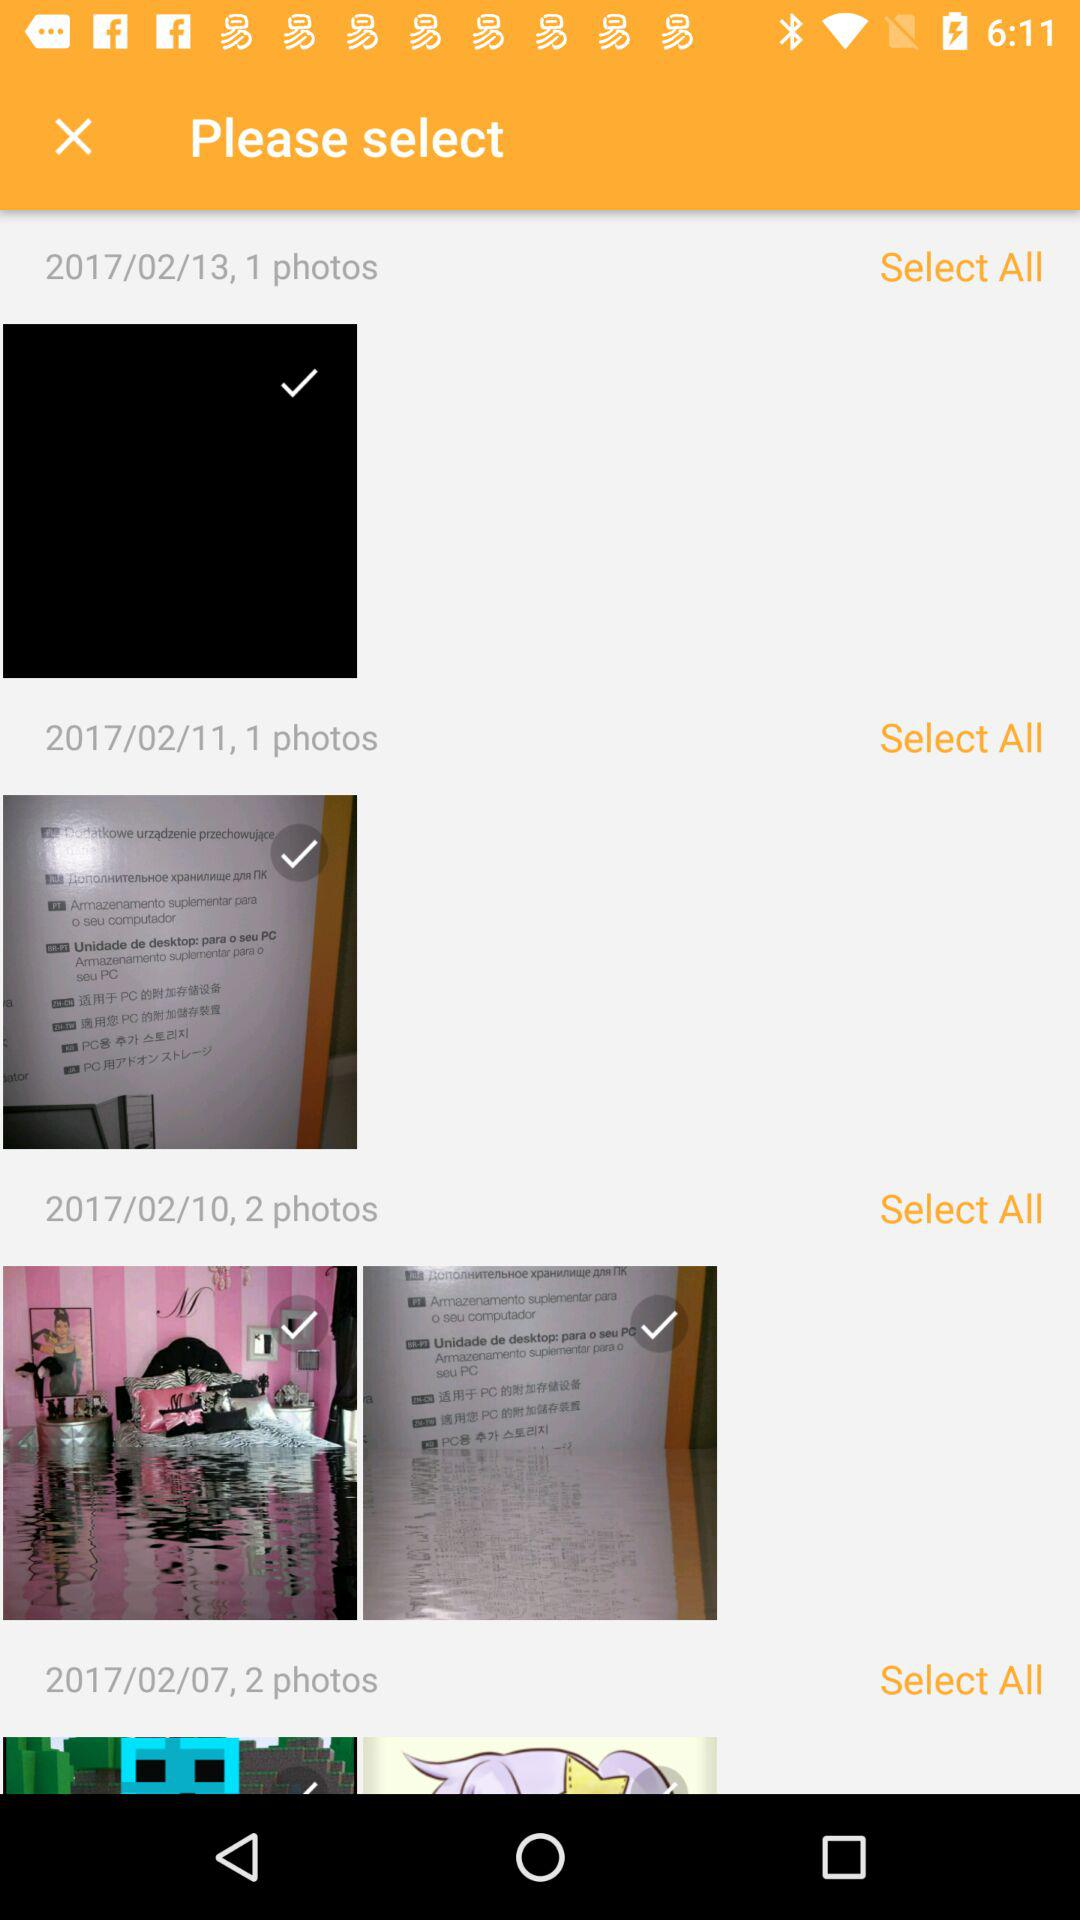What is the number of photos under the date "2017/02/10"? The number of photos under the date "2017/02/10" is 2. 